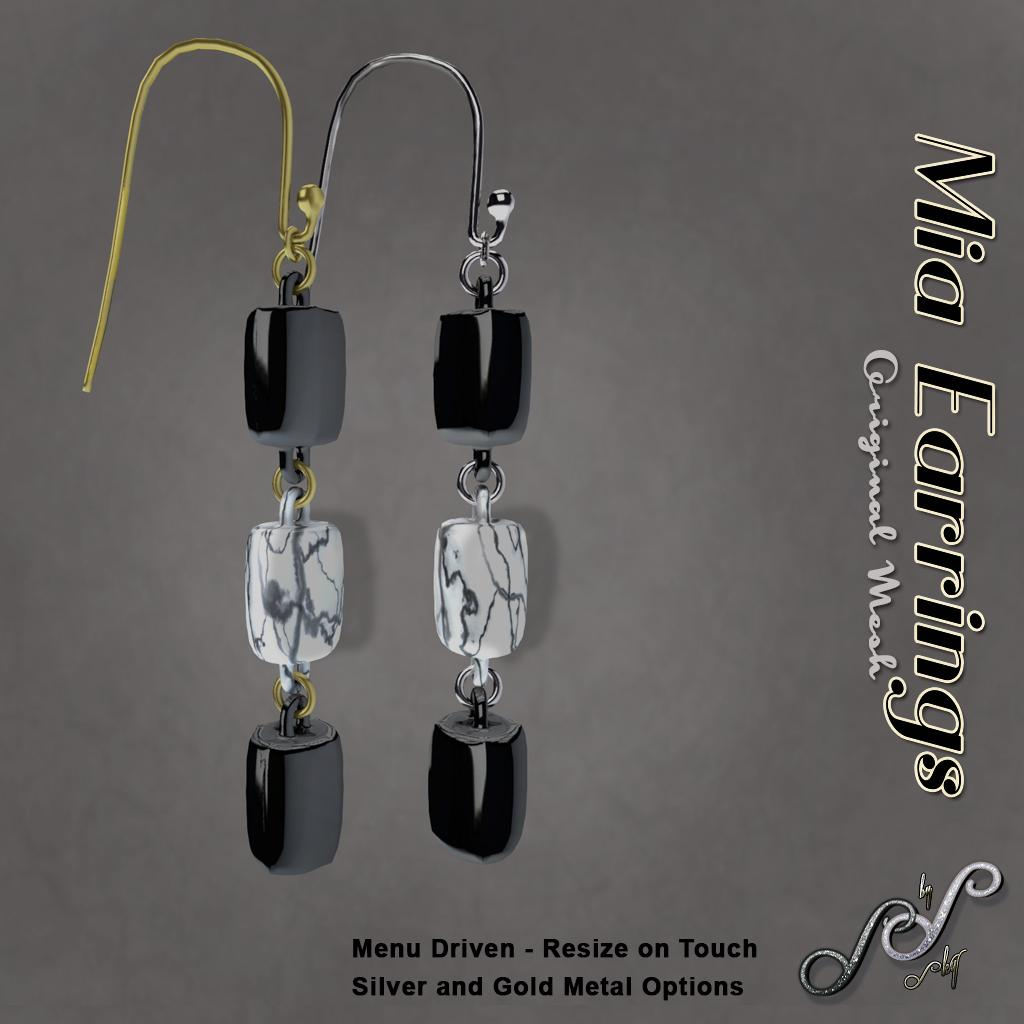What is the main subject of the image? The main subject of the image is a poster. What can be found on the poster? There is some information on the poster. Are there any objects or accessories visible in the image? Yes, there is a pair of earrings visible in the image. What type of pleasure can be seen on the poster? There is no indication of pleasure in the image, as it is a picture of a poster with information and a pair of earrings. 